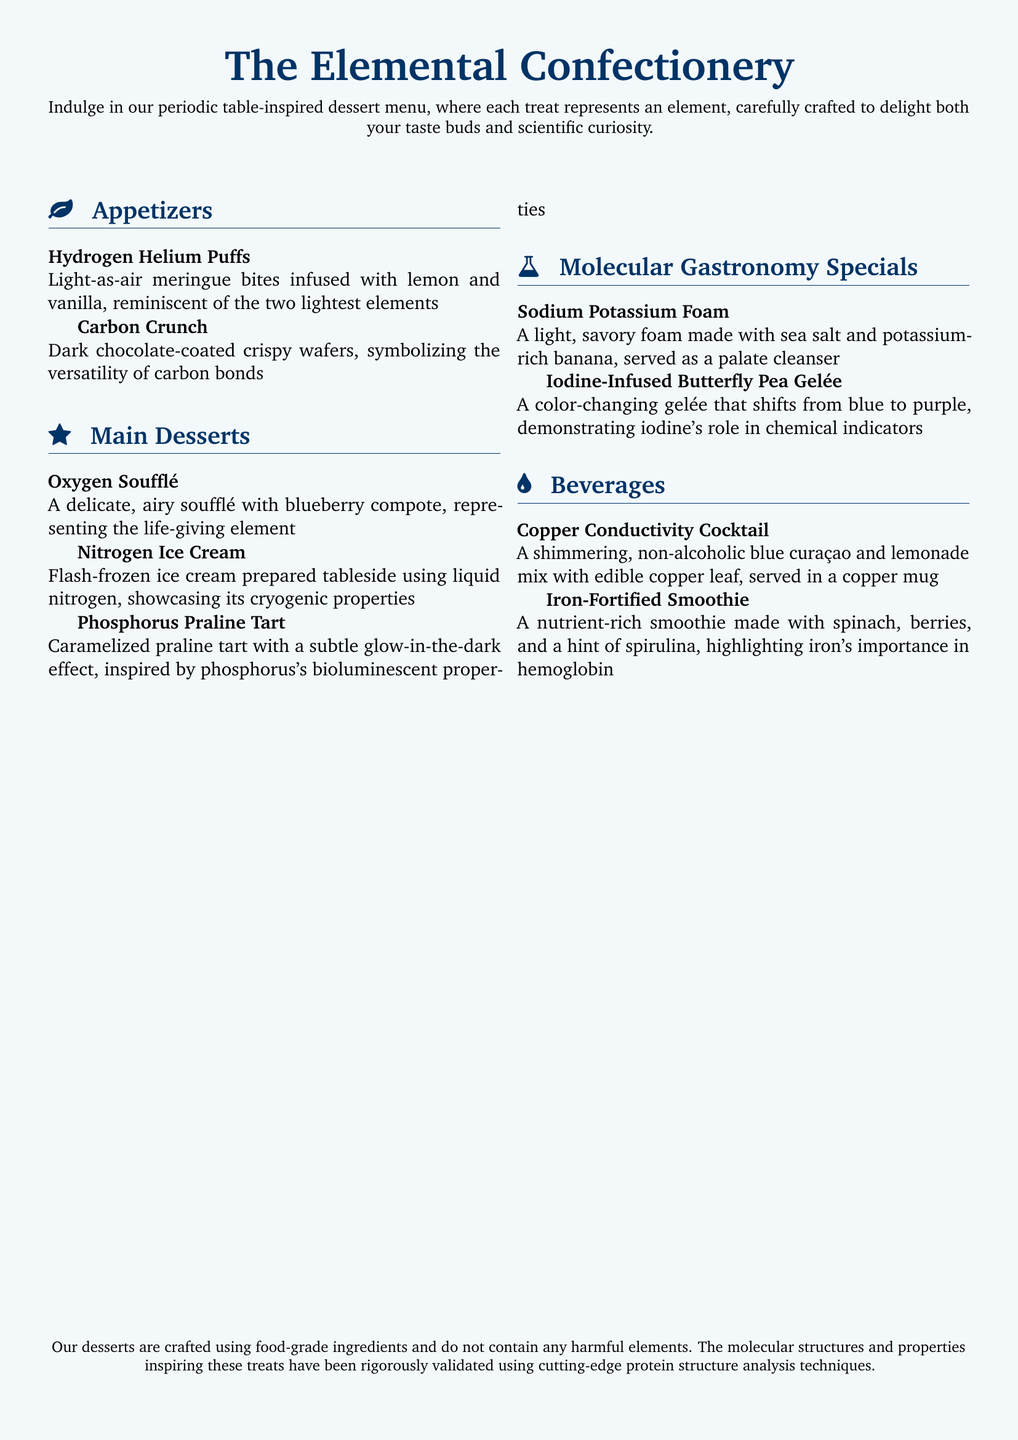What are the appetizers offered? The appetizers listed in the document are "Hydrogen Helium Puffs" and "Carbon Crunch."
Answer: Hydrogen Helium Puffs, Carbon Crunch What does the Oxygen Soufflé represent? The Oxygen Soufflé represents the life-giving element, which is oxygen.
Answer: Oxygen What is a unique feature of the Nitrogen Ice Cream? The Nitrogen Ice Cream is flash-frozen using liquid nitrogen, showcasing its cryogenic properties.
Answer: Flash-frozen using liquid nitrogen Which dessert has a glow-in-the-dark effect? The dessert with a glow-in-the-dark effect is the Phosphorus Praline Tart.
Answer: Phosphorus Praline Tart What color does the Iodine-Infused Butterfly Pea Gelée change to? The Iodine-Infused Butterfly Pea Gelée changes from blue to purple.
Answer: Blue to purple What is the Copper Conductivity Cocktail served in? The Copper Conductivity Cocktail is served in a copper mug.
Answer: Copper mug Which dessert serves as a palate cleanser? The Sodium Potassium Foam serves as a palate cleanser.
Answer: Sodium Potassium Foam What is emphasized about the ingredients used in the desserts? The document emphasizes that the desserts are crafted using food-grade ingredients and do not contain harmful elements.
Answer: Food-grade ingredients How are the molecular structures of the desserts validated? The molecular structures are validated using cutting-edge protein structure analysis techniques.
Answer: Protein structure analysis techniques 